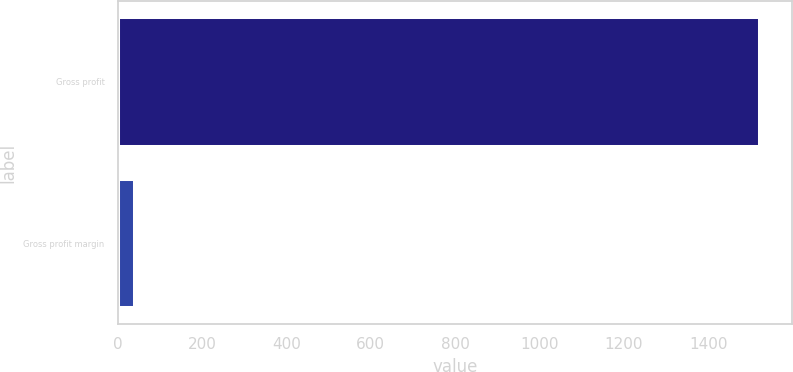Convert chart. <chart><loc_0><loc_0><loc_500><loc_500><bar_chart><fcel>Gross profit<fcel>Gross profit margin<nl><fcel>1522.5<fcel>41.2<nl></chart> 